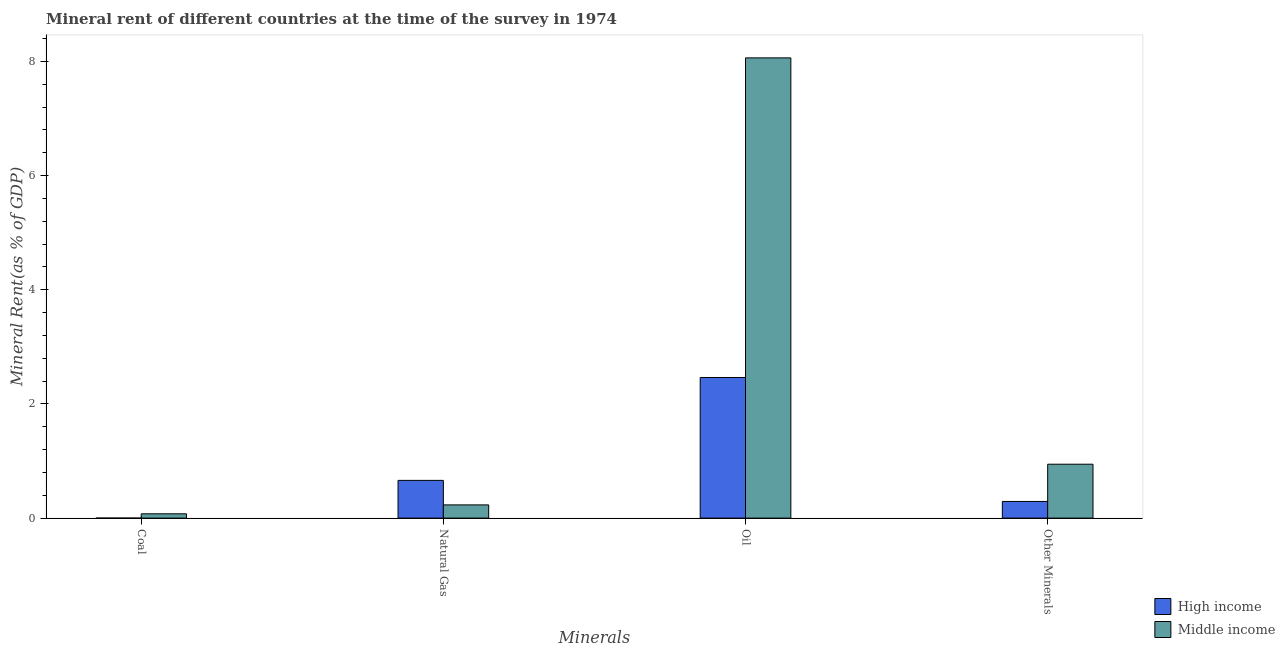How many different coloured bars are there?
Your response must be concise. 2. How many groups of bars are there?
Ensure brevity in your answer.  4. What is the label of the 2nd group of bars from the left?
Provide a succinct answer. Natural Gas. What is the oil rent in Middle income?
Keep it short and to the point. 8.06. Across all countries, what is the maximum coal rent?
Your answer should be very brief. 0.08. Across all countries, what is the minimum natural gas rent?
Offer a very short reply. 0.23. What is the total  rent of other minerals in the graph?
Offer a terse response. 1.24. What is the difference between the natural gas rent in High income and that in Middle income?
Keep it short and to the point. 0.43. What is the difference between the natural gas rent in High income and the coal rent in Middle income?
Your response must be concise. 0.59. What is the average natural gas rent per country?
Make the answer very short. 0.45. What is the difference between the coal rent and  rent of other minerals in High income?
Make the answer very short. -0.29. What is the ratio of the  rent of other minerals in High income to that in Middle income?
Your answer should be very brief. 0.31. Is the natural gas rent in High income less than that in Middle income?
Offer a terse response. No. Is the difference between the  rent of other minerals in Middle income and High income greater than the difference between the natural gas rent in Middle income and High income?
Offer a terse response. Yes. What is the difference between the highest and the second highest  rent of other minerals?
Offer a very short reply. 0.65. What is the difference between the highest and the lowest  rent of other minerals?
Ensure brevity in your answer.  0.65. Is the sum of the  rent of other minerals in High income and Middle income greater than the maximum coal rent across all countries?
Give a very brief answer. Yes. Is it the case that in every country, the sum of the coal rent and  rent of other minerals is greater than the sum of oil rent and natural gas rent?
Provide a succinct answer. No. What does the 1st bar from the left in Natural Gas represents?
Provide a succinct answer. High income. Is it the case that in every country, the sum of the coal rent and natural gas rent is greater than the oil rent?
Give a very brief answer. No. How many bars are there?
Offer a terse response. 8. How many countries are there in the graph?
Offer a very short reply. 2. Are the values on the major ticks of Y-axis written in scientific E-notation?
Make the answer very short. No. How many legend labels are there?
Offer a very short reply. 2. What is the title of the graph?
Ensure brevity in your answer.  Mineral rent of different countries at the time of the survey in 1974. Does "Belarus" appear as one of the legend labels in the graph?
Your answer should be compact. No. What is the label or title of the X-axis?
Provide a short and direct response. Minerals. What is the label or title of the Y-axis?
Ensure brevity in your answer.  Mineral Rent(as % of GDP). What is the Mineral Rent(as % of GDP) in High income in Coal?
Provide a short and direct response. 0. What is the Mineral Rent(as % of GDP) in Middle income in Coal?
Ensure brevity in your answer.  0.08. What is the Mineral Rent(as % of GDP) of High income in Natural Gas?
Offer a very short reply. 0.66. What is the Mineral Rent(as % of GDP) of Middle income in Natural Gas?
Your answer should be compact. 0.23. What is the Mineral Rent(as % of GDP) in High income in Oil?
Ensure brevity in your answer.  2.46. What is the Mineral Rent(as % of GDP) in Middle income in Oil?
Ensure brevity in your answer.  8.06. What is the Mineral Rent(as % of GDP) in High income in Other Minerals?
Offer a terse response. 0.29. What is the Mineral Rent(as % of GDP) of Middle income in Other Minerals?
Your response must be concise. 0.94. Across all Minerals, what is the maximum Mineral Rent(as % of GDP) of High income?
Your answer should be compact. 2.46. Across all Minerals, what is the maximum Mineral Rent(as % of GDP) of Middle income?
Keep it short and to the point. 8.06. Across all Minerals, what is the minimum Mineral Rent(as % of GDP) of High income?
Your answer should be compact. 0. Across all Minerals, what is the minimum Mineral Rent(as % of GDP) in Middle income?
Your answer should be very brief. 0.08. What is the total Mineral Rent(as % of GDP) of High income in the graph?
Ensure brevity in your answer.  3.42. What is the total Mineral Rent(as % of GDP) in Middle income in the graph?
Ensure brevity in your answer.  9.31. What is the difference between the Mineral Rent(as % of GDP) in High income in Coal and that in Natural Gas?
Offer a very short reply. -0.66. What is the difference between the Mineral Rent(as % of GDP) of Middle income in Coal and that in Natural Gas?
Provide a short and direct response. -0.16. What is the difference between the Mineral Rent(as % of GDP) in High income in Coal and that in Oil?
Provide a short and direct response. -2.46. What is the difference between the Mineral Rent(as % of GDP) of Middle income in Coal and that in Oil?
Provide a short and direct response. -7.99. What is the difference between the Mineral Rent(as % of GDP) of High income in Coal and that in Other Minerals?
Provide a short and direct response. -0.29. What is the difference between the Mineral Rent(as % of GDP) in Middle income in Coal and that in Other Minerals?
Ensure brevity in your answer.  -0.87. What is the difference between the Mineral Rent(as % of GDP) in High income in Natural Gas and that in Oil?
Give a very brief answer. -1.8. What is the difference between the Mineral Rent(as % of GDP) in Middle income in Natural Gas and that in Oil?
Offer a terse response. -7.83. What is the difference between the Mineral Rent(as % of GDP) of High income in Natural Gas and that in Other Minerals?
Keep it short and to the point. 0.37. What is the difference between the Mineral Rent(as % of GDP) of Middle income in Natural Gas and that in Other Minerals?
Keep it short and to the point. -0.71. What is the difference between the Mineral Rent(as % of GDP) of High income in Oil and that in Other Minerals?
Ensure brevity in your answer.  2.17. What is the difference between the Mineral Rent(as % of GDP) in Middle income in Oil and that in Other Minerals?
Your response must be concise. 7.12. What is the difference between the Mineral Rent(as % of GDP) of High income in Coal and the Mineral Rent(as % of GDP) of Middle income in Natural Gas?
Make the answer very short. -0.23. What is the difference between the Mineral Rent(as % of GDP) of High income in Coal and the Mineral Rent(as % of GDP) of Middle income in Oil?
Ensure brevity in your answer.  -8.06. What is the difference between the Mineral Rent(as % of GDP) of High income in Coal and the Mineral Rent(as % of GDP) of Middle income in Other Minerals?
Your answer should be compact. -0.94. What is the difference between the Mineral Rent(as % of GDP) in High income in Natural Gas and the Mineral Rent(as % of GDP) in Middle income in Oil?
Give a very brief answer. -7.4. What is the difference between the Mineral Rent(as % of GDP) in High income in Natural Gas and the Mineral Rent(as % of GDP) in Middle income in Other Minerals?
Keep it short and to the point. -0.28. What is the difference between the Mineral Rent(as % of GDP) in High income in Oil and the Mineral Rent(as % of GDP) in Middle income in Other Minerals?
Make the answer very short. 1.52. What is the average Mineral Rent(as % of GDP) in High income per Minerals?
Offer a terse response. 0.85. What is the average Mineral Rent(as % of GDP) of Middle income per Minerals?
Your answer should be compact. 2.33. What is the difference between the Mineral Rent(as % of GDP) of High income and Mineral Rent(as % of GDP) of Middle income in Coal?
Make the answer very short. -0.08. What is the difference between the Mineral Rent(as % of GDP) in High income and Mineral Rent(as % of GDP) in Middle income in Natural Gas?
Keep it short and to the point. 0.43. What is the difference between the Mineral Rent(as % of GDP) of High income and Mineral Rent(as % of GDP) of Middle income in Oil?
Give a very brief answer. -5.6. What is the difference between the Mineral Rent(as % of GDP) of High income and Mineral Rent(as % of GDP) of Middle income in Other Minerals?
Provide a short and direct response. -0.65. What is the ratio of the Mineral Rent(as % of GDP) in Middle income in Coal to that in Natural Gas?
Make the answer very short. 0.33. What is the ratio of the Mineral Rent(as % of GDP) of High income in Coal to that in Oil?
Offer a very short reply. 0. What is the ratio of the Mineral Rent(as % of GDP) in Middle income in Coal to that in Oil?
Your answer should be very brief. 0.01. What is the ratio of the Mineral Rent(as % of GDP) in High income in Coal to that in Other Minerals?
Offer a very short reply. 0. What is the ratio of the Mineral Rent(as % of GDP) in Middle income in Coal to that in Other Minerals?
Your answer should be compact. 0.08. What is the ratio of the Mineral Rent(as % of GDP) of High income in Natural Gas to that in Oil?
Your answer should be compact. 0.27. What is the ratio of the Mineral Rent(as % of GDP) of Middle income in Natural Gas to that in Oil?
Give a very brief answer. 0.03. What is the ratio of the Mineral Rent(as % of GDP) of High income in Natural Gas to that in Other Minerals?
Your answer should be very brief. 2.26. What is the ratio of the Mineral Rent(as % of GDP) of Middle income in Natural Gas to that in Other Minerals?
Make the answer very short. 0.25. What is the ratio of the Mineral Rent(as % of GDP) of High income in Oil to that in Other Minerals?
Give a very brief answer. 8.43. What is the ratio of the Mineral Rent(as % of GDP) in Middle income in Oil to that in Other Minerals?
Your response must be concise. 8.54. What is the difference between the highest and the second highest Mineral Rent(as % of GDP) in High income?
Give a very brief answer. 1.8. What is the difference between the highest and the second highest Mineral Rent(as % of GDP) of Middle income?
Offer a very short reply. 7.12. What is the difference between the highest and the lowest Mineral Rent(as % of GDP) in High income?
Give a very brief answer. 2.46. What is the difference between the highest and the lowest Mineral Rent(as % of GDP) in Middle income?
Ensure brevity in your answer.  7.99. 